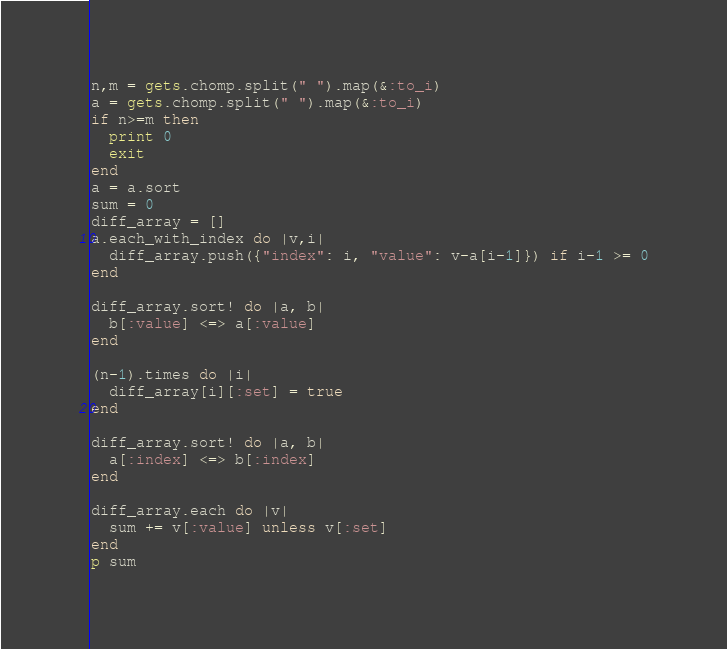<code> <loc_0><loc_0><loc_500><loc_500><_Ruby_>n,m = gets.chomp.split(" ").map(&:to_i)
a = gets.chomp.split(" ").map(&:to_i)
if n>=m then
  print 0
  exit
end
a = a.sort
sum = 0
diff_array = []
a.each_with_index do |v,i|
  diff_array.push({"index": i, "value": v-a[i-1]}) if i-1 >= 0
end

diff_array.sort! do |a, b|
  b[:value] <=> a[:value]
end

(n-1).times do |i|
  diff_array[i][:set] = true
end

diff_array.sort! do |a, b|
  a[:index] <=> b[:index]
end

diff_array.each do |v|
  sum += v[:value] unless v[:set]
end
p sum</code> 